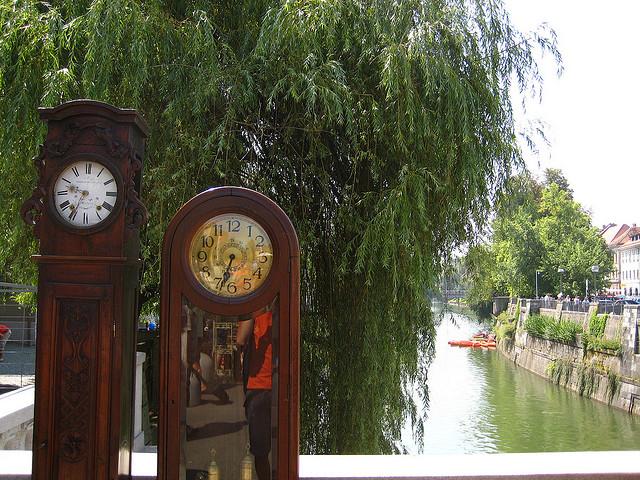Are these digital clocks?
Write a very short answer. No. Are the clock old?
Short answer required. Yes. What times do the clocks say?
Give a very brief answer. 9:35. 